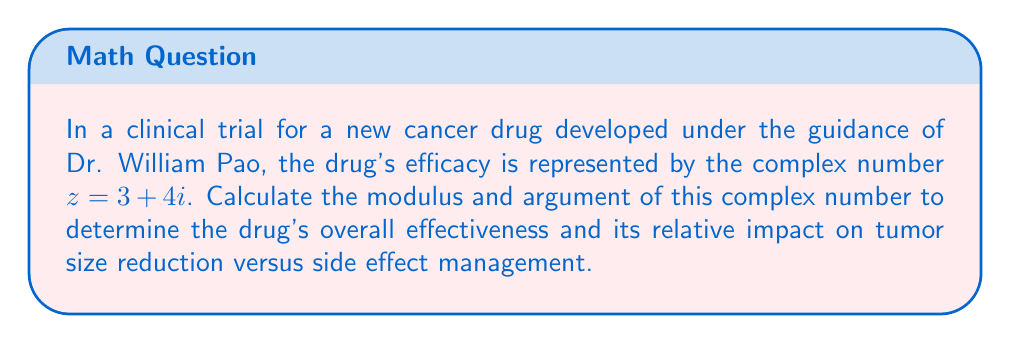Can you answer this question? To calculate the modulus and argument of the complex number $z = 3 + 4i$, we'll follow these steps:

1. Modulus calculation:
   The modulus of a complex number $z = a + bi$ is given by the formula:
   $$|z| = \sqrt{a^2 + b^2}$$
   
   For $z = 3 + 4i$:
   $$|z| = \sqrt{3^2 + 4^2} = \sqrt{9 + 16} = \sqrt{25} = 5$$

2. Argument calculation:
   The argument of a complex number is the angle it makes with the positive real axis in the complex plane. It's calculated using the arctangent function:
   $$\arg(z) = \tan^{-1}\left(\frac{b}{a}\right)$$
   
   For $z = 3 + 4i$:
   $$\arg(z) = \tan^{-1}\left(\frac{4}{3}\right) \approx 0.9273 \text{ radians}$$

   To convert to degrees:
   $$0.9273 \text{ radians} \times \frac{180°}{\pi} \approx 53.13°$$

The modulus (5) represents the overall effectiveness of the drug, while the argument (53.13°) indicates the balance between tumor size reduction (real part) and side effect management (imaginary part).
Answer: Modulus: 5, Argument: 53.13° 